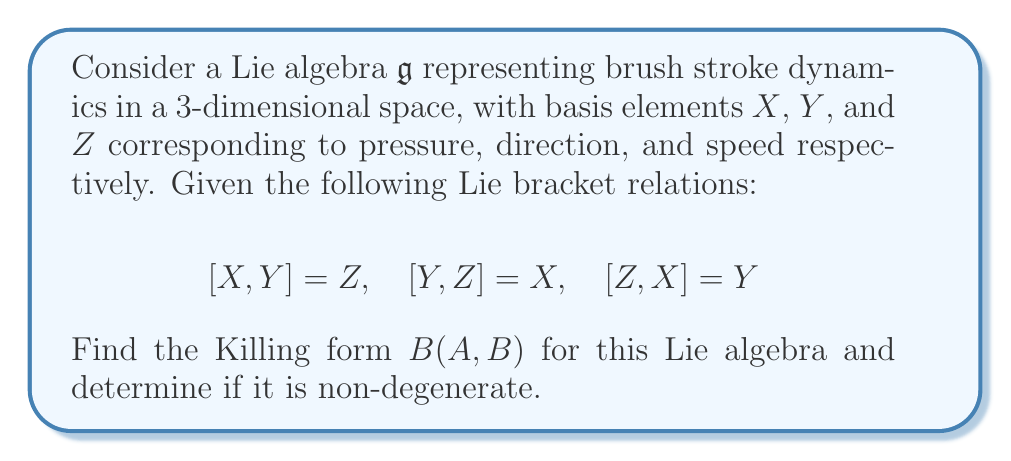Can you solve this math problem? To find the Killing form of this Lie algebra, we need to follow these steps:

1) The Killing form is defined as $B(A,B) = \text{tr}(\text{ad}(A) \circ \text{ad}(B))$, where $\text{ad}(A)$ is the adjoint representation of $A$.

2) First, let's calculate the adjoint representations of $X$, $Y$, and $Z$:

   $\text{ad}(X) = \begin{pmatrix} 0 & 0 & -1 \\ 0 & 0 & 1 \\ 1 & -1 & 0 \end{pmatrix}$

   $\text{ad}(Y) = \begin{pmatrix} 0 & 0 & 1 \\ 0 & 0 & -1 \\ -1 & 1 & 0 \end{pmatrix}$

   $\text{ad}(Z) = \begin{pmatrix} 0 & -1 & 0 \\ 1 & 0 & 0 \\ 0 & 0 & 0 \end{pmatrix}$

3) Now, let's calculate $B(X,X)$, $B(Y,Y)$, and $B(Z,Z)$:

   $B(X,X) = \text{tr}(\text{ad}(X) \circ \text{ad}(X)) = \text{tr}(\begin{pmatrix} -1 & 1 & 0 \\ -1 & 1 & 0 \\ 0 & 0 & 2 \end{pmatrix}) = 2$

   Similarly, $B(Y,Y) = 2$ and $B(Z,Z) = 2$

4) For the cross terms:

   $B(X,Y) = \text{tr}(\text{ad}(X) \circ \text{ad}(Y)) = \text{tr}(\begin{pmatrix} -1 & 1 & 0 \\ -1 & 1 & 0 \\ 0 & 0 & -2 \end{pmatrix}) = -2$

   Similarly, $B(Y,Z) = B(Z,X) = -2$

5) The Killing form matrix is thus:

   $B = \begin{pmatrix} 2 & -2 & -2 \\ -2 & 2 & -2 \\ -2 & -2 & 2 \end{pmatrix}$

6) To determine if it's non-degenerate, we calculate the determinant:

   $\det(B) = 2(2(2) - (-2)(-2)) - (-2)((-2)(2) - (-2)(-2)) = -24$

As the determinant is non-zero, the Killing form is non-degenerate.
Answer: The Killing form for the given Lie algebra is:

$$B = \begin{pmatrix} 2 & -2 & -2 \\ -2 & 2 & -2 \\ -2 & -2 & 2 \end{pmatrix}$$

It is non-degenerate as $\det(B) = -24 \neq 0$. 